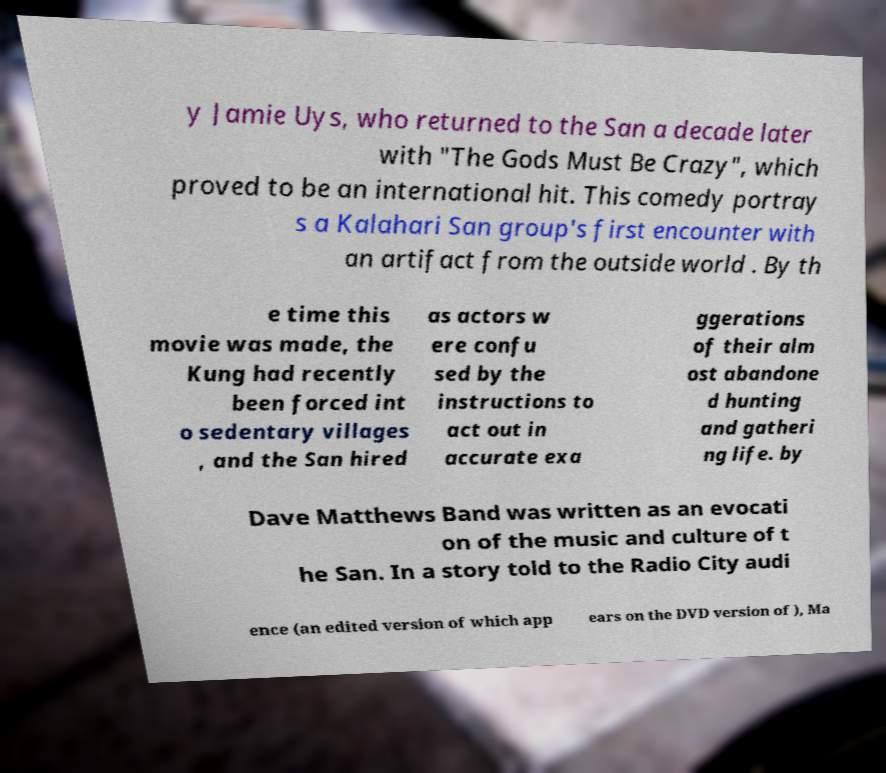Can you accurately transcribe the text from the provided image for me? y Jamie Uys, who returned to the San a decade later with "The Gods Must Be Crazy", which proved to be an international hit. This comedy portray s a Kalahari San group's first encounter with an artifact from the outside world . By th e time this movie was made, the Kung had recently been forced int o sedentary villages , and the San hired as actors w ere confu sed by the instructions to act out in accurate exa ggerations of their alm ost abandone d hunting and gatheri ng life. by Dave Matthews Band was written as an evocati on of the music and culture of t he San. In a story told to the Radio City audi ence (an edited version of which app ears on the DVD version of ), Ma 